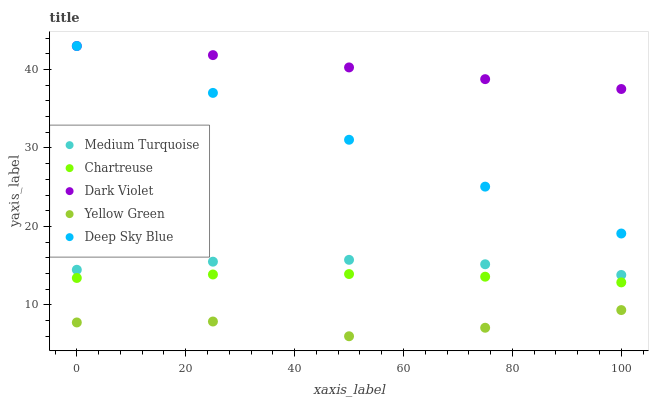Does Yellow Green have the minimum area under the curve?
Answer yes or no. Yes. Does Dark Violet have the maximum area under the curve?
Answer yes or no. Yes. Does Chartreuse have the minimum area under the curve?
Answer yes or no. No. Does Chartreuse have the maximum area under the curve?
Answer yes or no. No. Is Deep Sky Blue the smoothest?
Answer yes or no. Yes. Is Yellow Green the roughest?
Answer yes or no. Yes. Is Chartreuse the smoothest?
Answer yes or no. No. Is Chartreuse the roughest?
Answer yes or no. No. Does Yellow Green have the lowest value?
Answer yes or no. Yes. Does Chartreuse have the lowest value?
Answer yes or no. No. Does Dark Violet have the highest value?
Answer yes or no. Yes. Does Chartreuse have the highest value?
Answer yes or no. No. Is Chartreuse less than Dark Violet?
Answer yes or no. Yes. Is Medium Turquoise greater than Yellow Green?
Answer yes or no. Yes. Does Deep Sky Blue intersect Dark Violet?
Answer yes or no. Yes. Is Deep Sky Blue less than Dark Violet?
Answer yes or no. No. Is Deep Sky Blue greater than Dark Violet?
Answer yes or no. No. Does Chartreuse intersect Dark Violet?
Answer yes or no. No. 